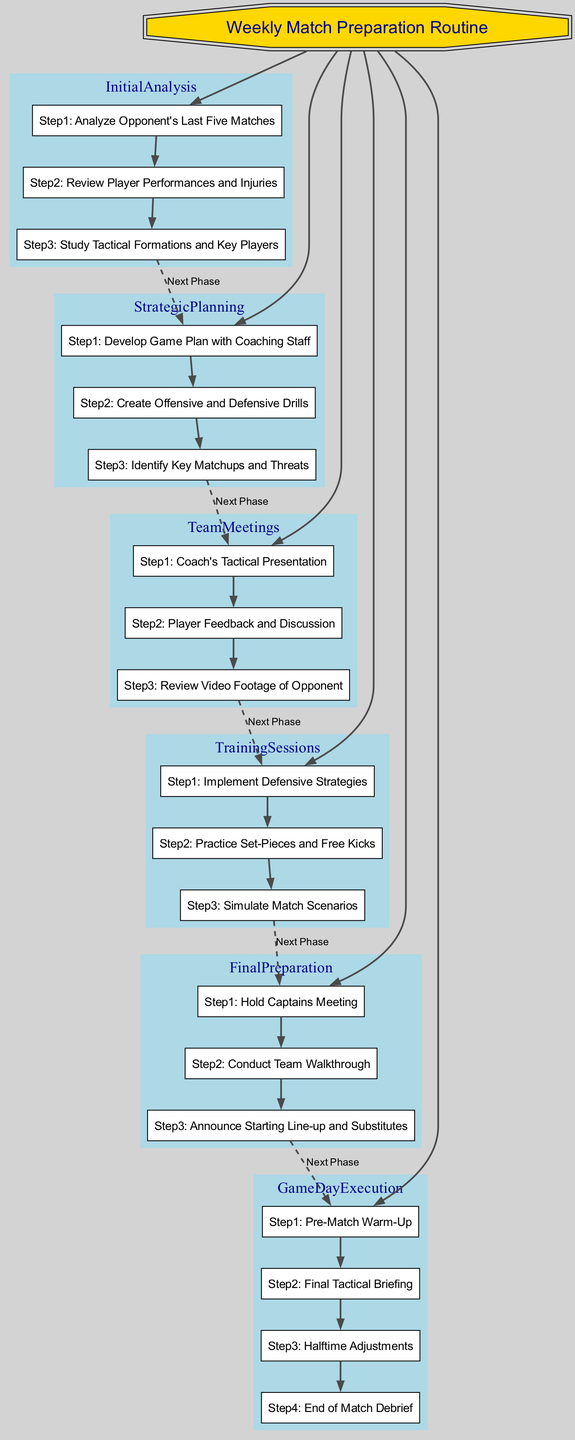What is the first step in Initial Analysis? The first step in the Initial Analysis phase is to analyze the opponent's last five matches, as indicated in the diagram.
Answer: Analyze Opponent's Last Five Matches How many steps are there in Final Preparation? The diagram shows that there are three distinct steps in the Final Preparation phase.
Answer: 3 Which phase comes after Team Meetings? By following the flow of the diagram, the phase that comes after Team Meetings is Training Sessions.
Answer: Training Sessions What are the last two steps of Game Day Execution? The last two steps in the Game Day Execution phase, as shown in the diagram, are Halftime Adjustments and End of Match Debrief.
Answer: Halftime Adjustments and End of Match Debrief How many phases are there in total? The diagram indicates that there are six different phases involved in the weekly match preparation routine.
Answer: 6 Which step reviews player performances? The step that reviews player performances is Step 2 in the Initial Analysis phase according to the diagram.
Answer: Review Player Performances and Injuries What is the relationship between Initial Analysis and Strategic Planning? The relationship is that Initial Analysis is completed before moving to Strategic Planning, indicated by the dashed line showing the flow of phases from one to the other in the diagram.
Answer: Initial Analysis precedes Strategic Planning Which phase concludes with a tactical presentation? The phase that concludes with a tactical presentation is Team Meetings, as clearly depicted in the diagram.
Answer: Team Meetings What is the main purpose of the Final Preparation phase? The main purpose is to conduct last-minute preparations critical for team alignment before the match, including a walkthrough and final team discussions, as stated in the diagram.
Answer: Final preparations before the match What step involves the practice of set-pieces? The step that involves the practice of set-pieces is Step 2 in the Training Sessions phase according to the diagram.
Answer: Practice Set-Pieces and Free Kicks 